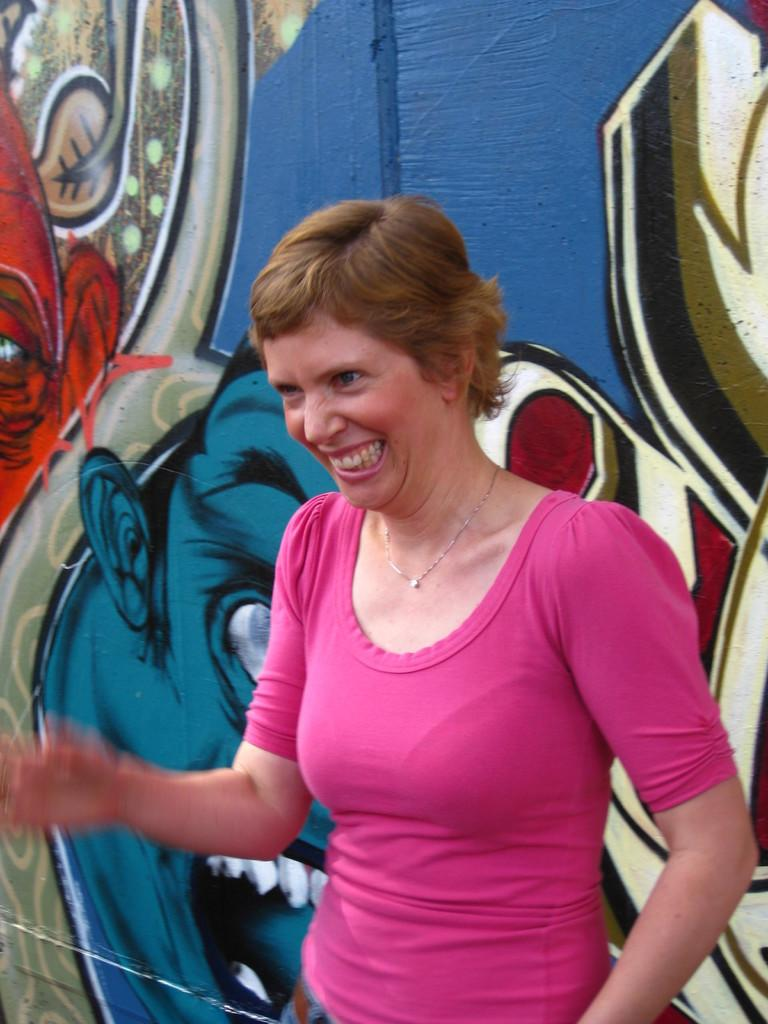What is the main subject of the image? There is a lady standing in the image. What can be seen behind the lady? There is a wall behind the lady. What is on the wall? There is a painting on the wall. What type of soup is being served in the image? There is no soup present in the image; it features a lady standing in front of a wall with a painting on it. 